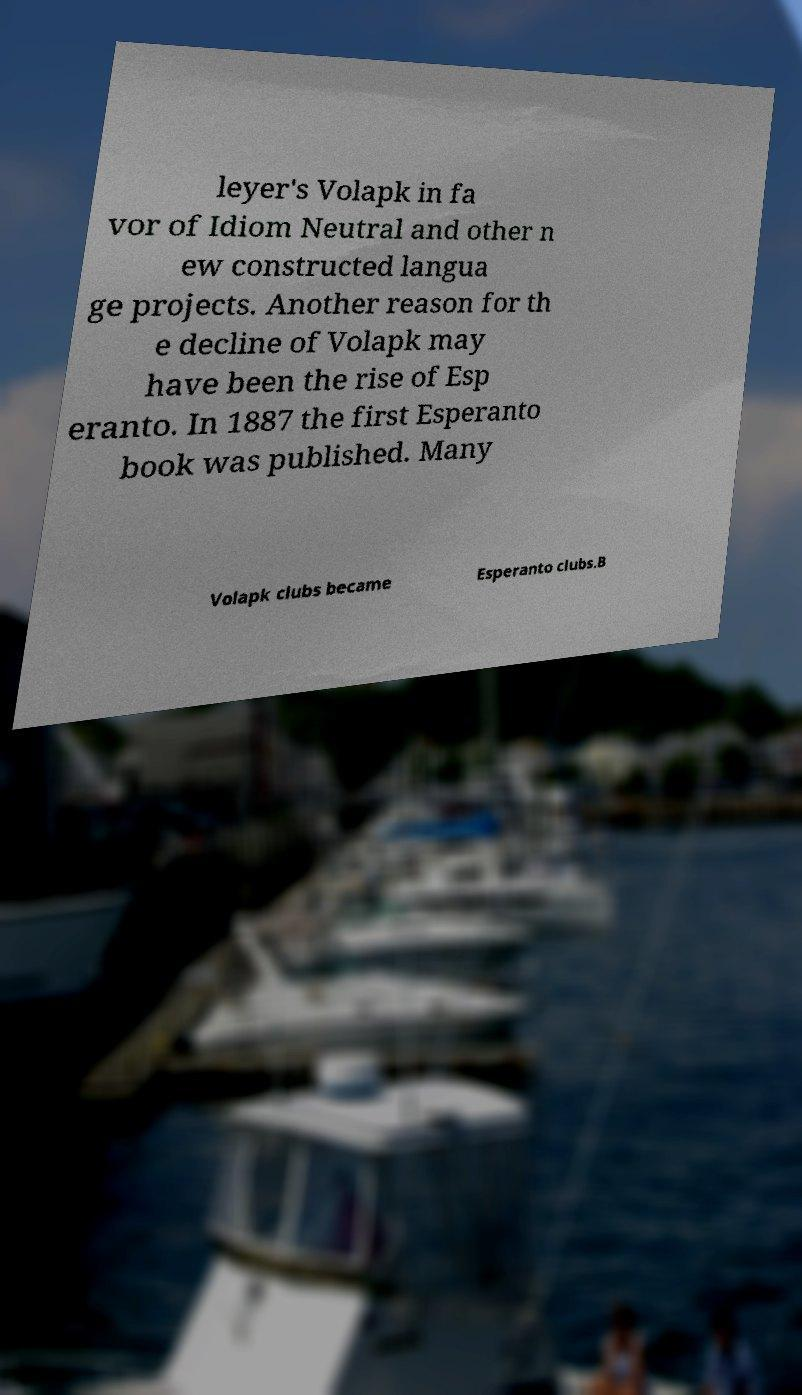Could you extract and type out the text from this image? leyer's Volapk in fa vor of Idiom Neutral and other n ew constructed langua ge projects. Another reason for th e decline of Volapk may have been the rise of Esp eranto. In 1887 the first Esperanto book was published. Many Volapk clubs became Esperanto clubs.B 